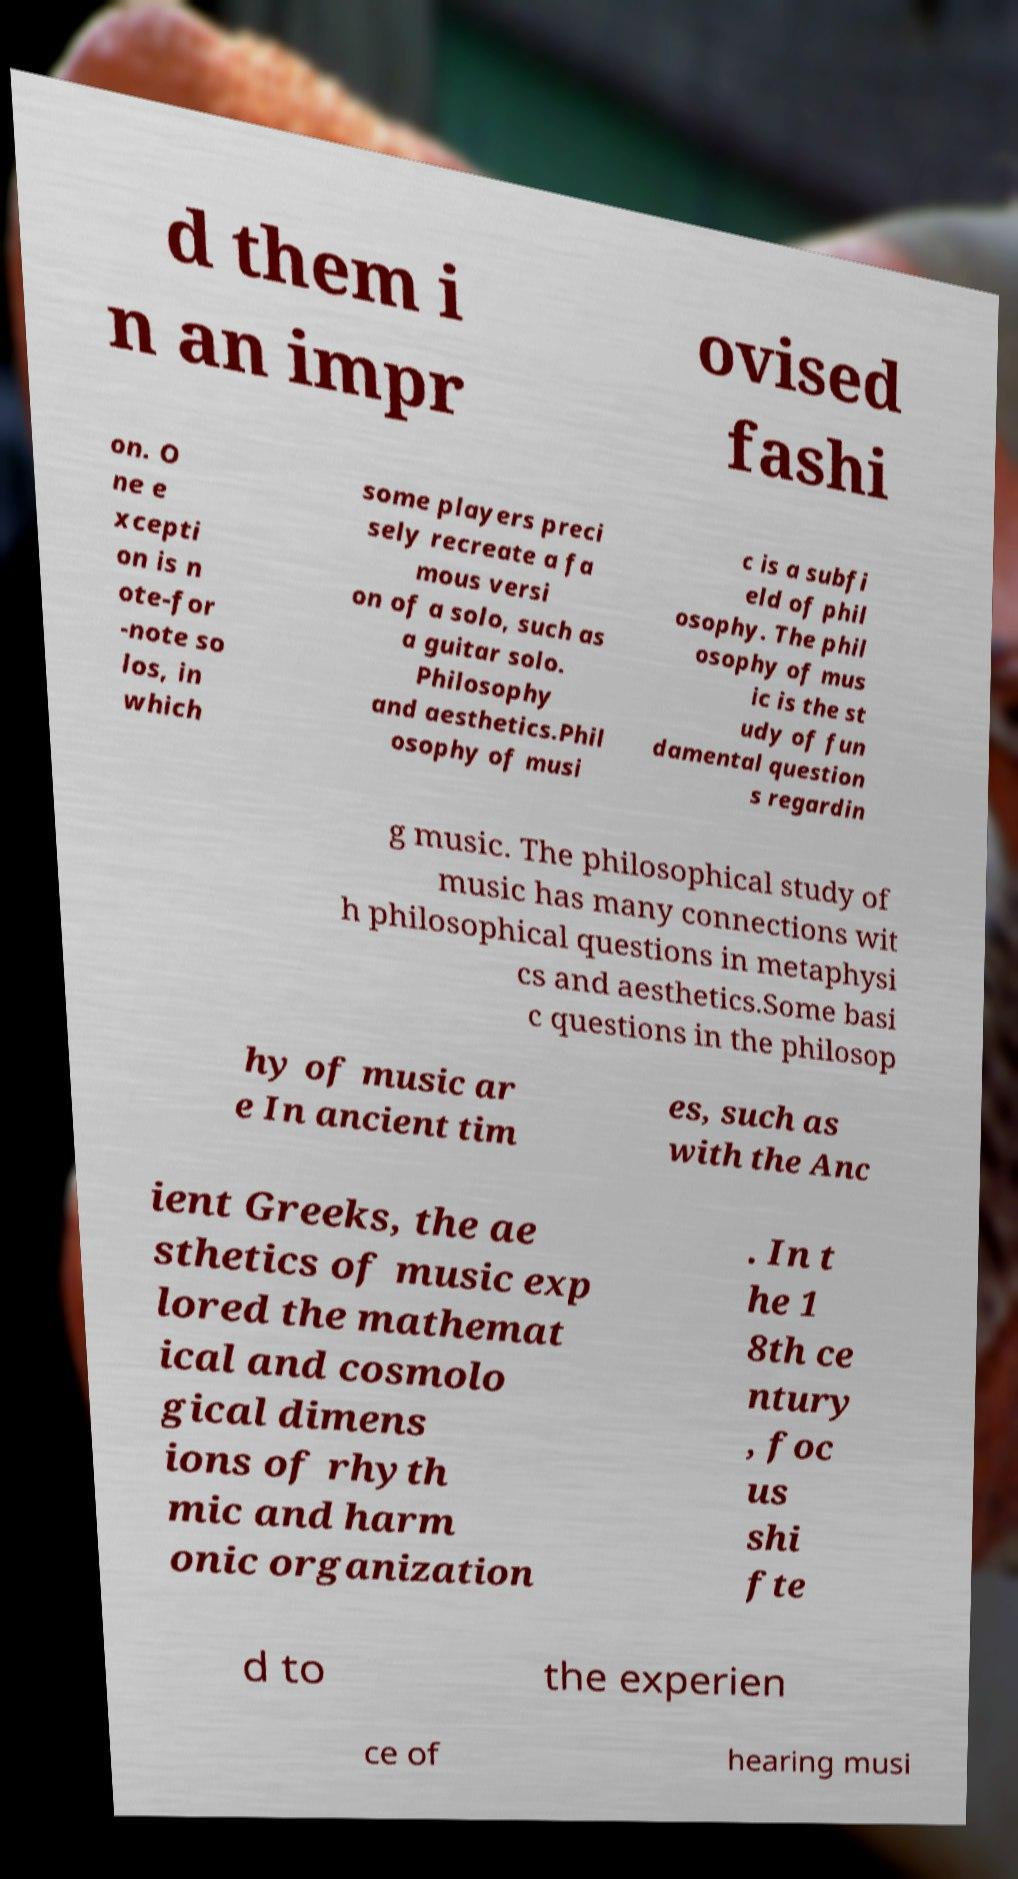Please identify and transcribe the text found in this image. d them i n an impr ovised fashi on. O ne e xcepti on is n ote-for -note so los, in which some players preci sely recreate a fa mous versi on of a solo, such as a guitar solo. Philosophy and aesthetics.Phil osophy of musi c is a subfi eld of phil osophy. The phil osophy of mus ic is the st udy of fun damental question s regardin g music. The philosophical study of music has many connections wit h philosophical questions in metaphysi cs and aesthetics.Some basi c questions in the philosop hy of music ar e In ancient tim es, such as with the Anc ient Greeks, the ae sthetics of music exp lored the mathemat ical and cosmolo gical dimens ions of rhyth mic and harm onic organization . In t he 1 8th ce ntury , foc us shi fte d to the experien ce of hearing musi 